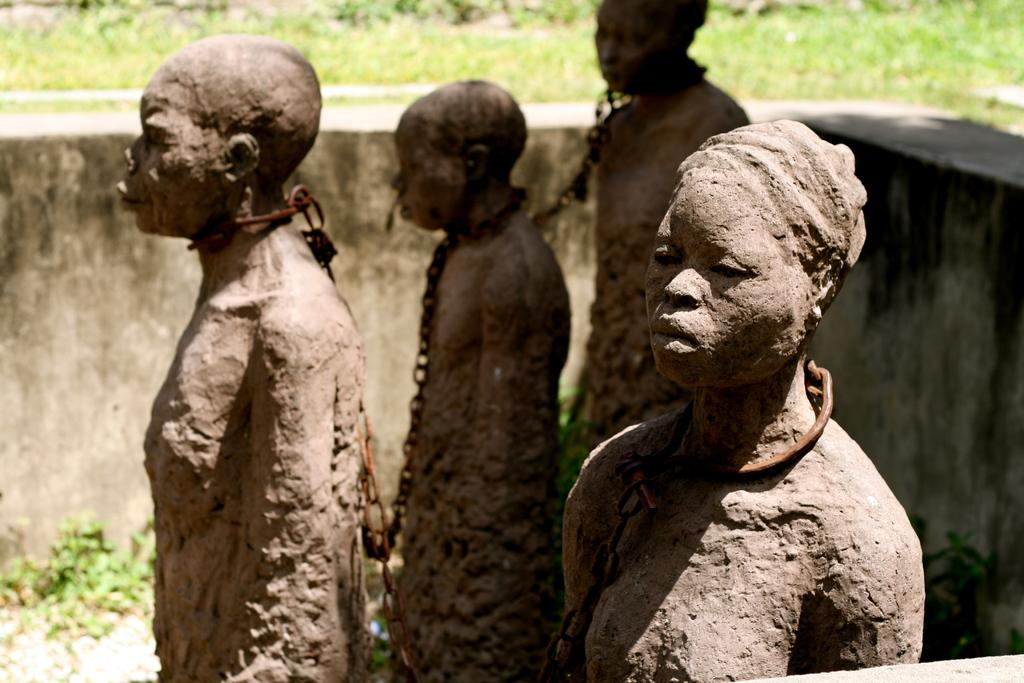What is the main subject of the image? The main subject of the image is many statues with chains. What can be seen in the background of the image? There is a wall in the background of the image. What type of natural environment is visible in the image? There is grass visible in the image. What word is being spelled out by the fairies in the garden in the image? There are no fairies or gardens present in the image, so it is not possible to determine if any word is being spelled out. 